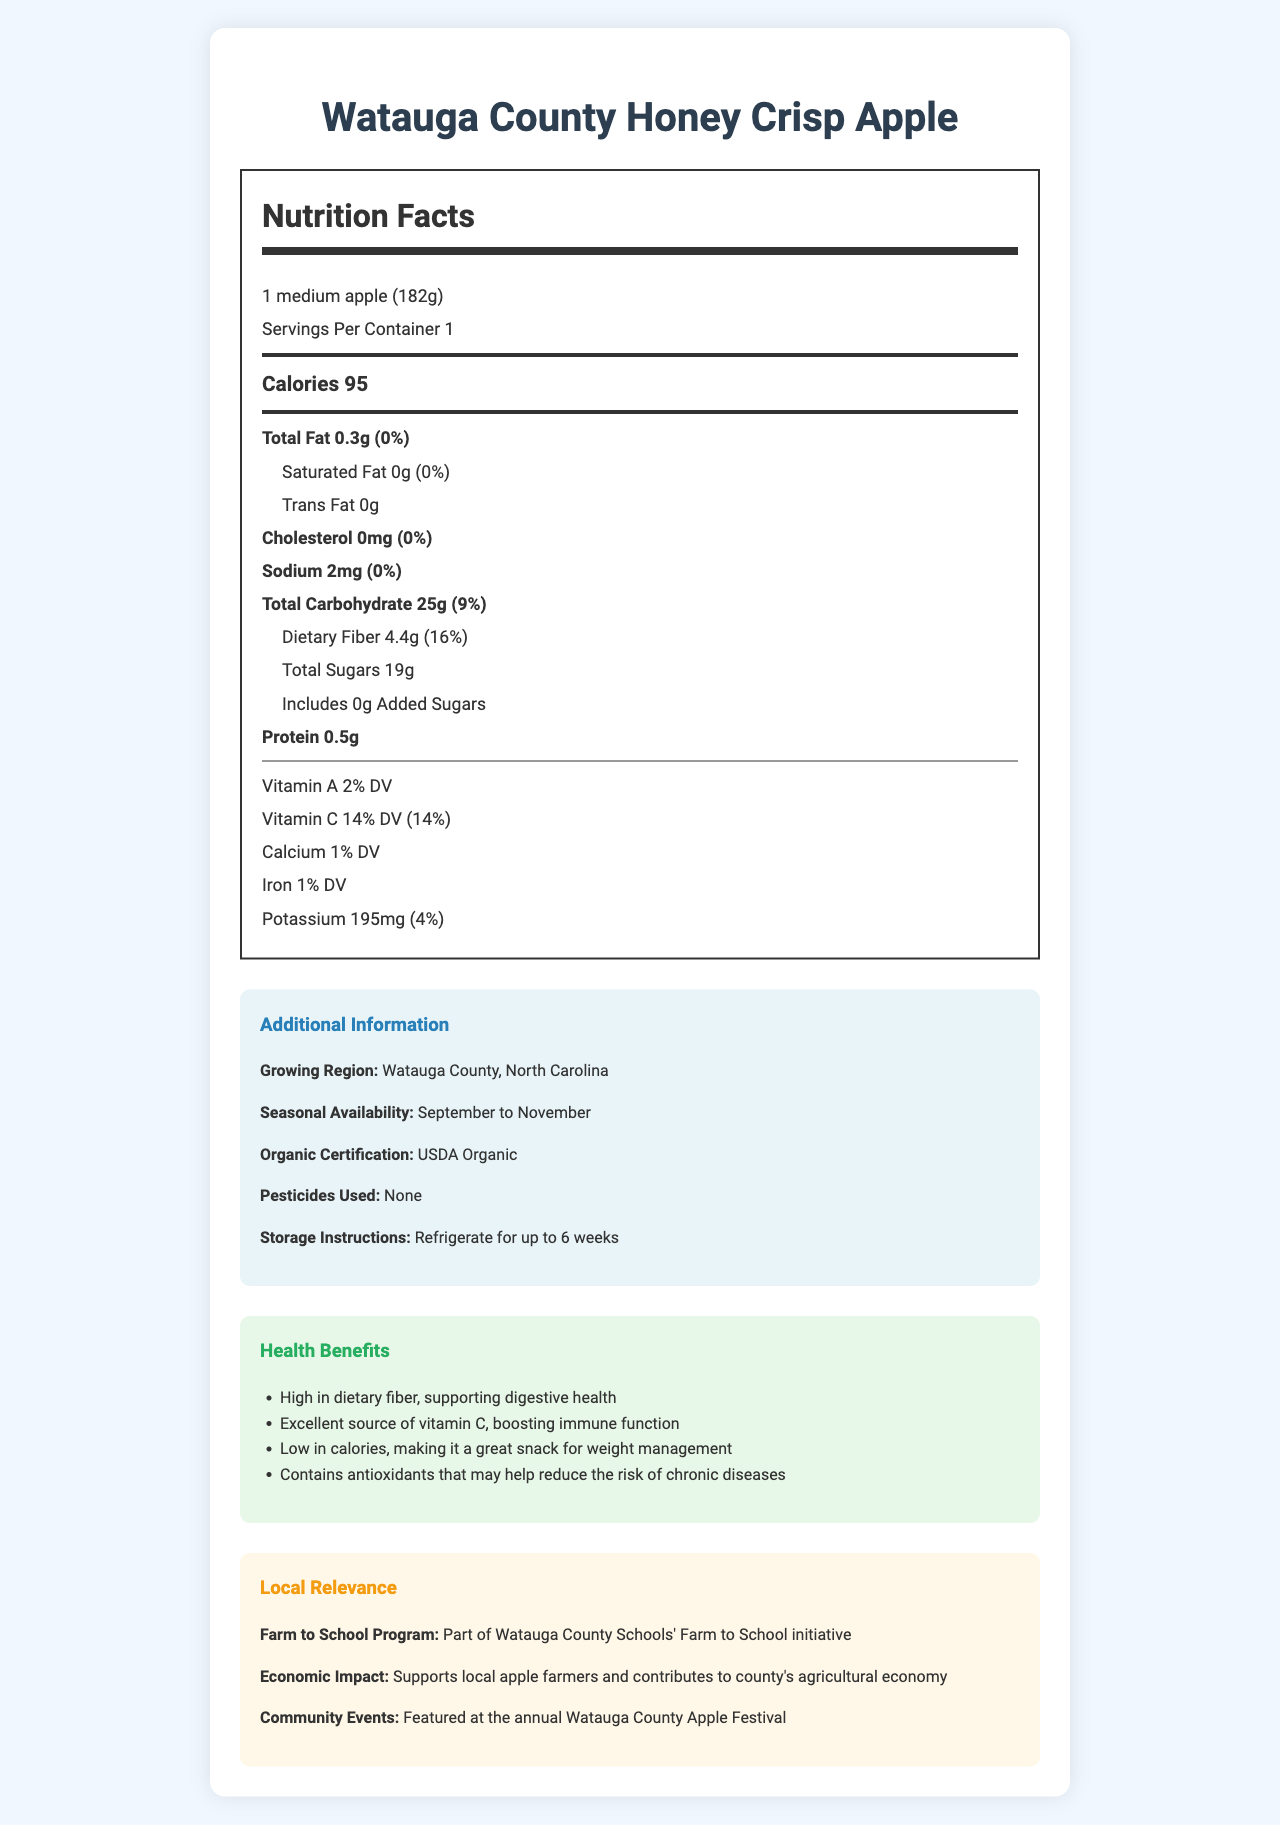what is the serving size of the Watauga County Honey Crisp Apple? The serving size is clearly mentioned at the top of the Nutrition Facts section.
Answer: 1 medium apple (182g) how many calories are there per serving? The document specifies that each serving contains 95 calories.
Answer: 95 calories what percentage of the Daily Value does the dietary fiber in the apple represent? In the Nutrition Facts section, it mentions that the dietary fiber content is 4.4g, which equals 16% of the Daily Value.
Answer: 16% what is the total carbohydrate content per serving? The total carbohydrate content is listed as 25g in the Nutrition Facts section.
Answer: 25g what is the vitamin C percentage of the Daily Value provided by one serving of the apple? The percentage of Daily Value for vitamin C is stated as 14%.
Answer: 14% when is the seasonal availability of the Watauga County Honey Crisp Apple? A. January to March B. April to June C. September to November D. December to February The Additional Information section states that the seasonal availability is September to November.
Answer: C how much protein does a serving of this apple contain? The protein content per serving is indicated as 0.5g in the Nutrition Facts section.
Answer: 0.5g is this apple USDA Organic certified? The Additional Information section confirms that the apple is USDA Organic certified.
Answer: Yes which nutrient has the highest Daily Value percentage? A. Vitamin A B. Vitamin C C. Dietary Fiber D. Potassium The dietary fiber has the highest Daily Value percentage, listed at 16%.
Answer: C are any pesticides used in growing this apple variety? The Additional Information section mentions that no pesticides are used.
Answer: No describe the main idea of the document. The document mainly focuses on giving a comprehensive view of the nutritional benefits and additional relevant details about this local apple variety, aimed at informing consumers and promoting local agriculture.
Answer: The document provides detailed nutritional information about the Watauga County Honey Crisp Apple, highlighting its high fiber and vitamin C content. It includes the serving size, calorie count, and percentages of various nutrients relative to Daily Values. Additionally, it offers additional information about the apple's growing region, availability, organic certification, and storage instructions, along with its health benefits and local relevance. what is the sugar content of the apple? The sugar content per serving is listed in the Nutrition Facts as 19g.
Answer: 19g how many milligrams of potassium does one apple contain? In the Nutrition Facts section, the potassium content is mentioned as 195mg.
Answer: 195mg how long can the apple be stored if refrigerated? The storage instructions in the Additional Information section indicate that the apple can be refrigerated for up to 6 weeks.
Answer: Up to 6 weeks what type of events feature this apple variety in the community? According to the Local Relevance section, this apple variety is featured at the annual Watauga County Apple Festival.
Answer: Watauga County Apple Festival does the apple contain any added sugars? The Nutrition Facts section specifies that the apple contains 0g of added sugars.
Answer: No, it contains 0g of added sugars. what is the economic impact of this local apple variety on Watauga County? The Local Relevance section explains that the apple supports local farmers and contributes to the agricultural economy.
Answer: Supports local apple farmers and contributes to the county's agricultural economy what is the cholesterol content in this apple? The cholesterol content is listed as 0mg in the Nutrition Facts section.
Answer: 0mg explain the health benefits associated with consuming this apple variety. The Health Benefits section outlines how the high fiber and vitamin C content contribute to better digestive and immune health, with additional benefits including low calorie content for weight management and the presence of antioxidants.
Answer: The apple is high in dietary fiber, supporting digestive health, and an excellent source of vitamin C, boosting immune function. It is low in calories, making it a great snack for weight management, and contains antioxidants that may help reduce the risk of chronic diseases. what are the types of fats present in this apple? The Nutrition Facts section lists the total fat as 0.3g, with 0g of both saturated and trans fats.
Answer: Total Fat: 0.3g, Saturated Fat: 0g, Trans Fat: 0g which vitamin has a higher Daily Value percentage, vitamin A or vitamin C? The Daily Value percentage for vitamin A is 2%, while for vitamin C it is 14%, indicating vitamin C has a higher Daily Value percentage.
Answer: Vitamin C what is the growing region for this apple variety? The Additional Information section states that the growing region is Watauga County, North Carolina.
Answer: Watauga County, North Carolina are any artificial sweeteners or flavorings added to this apple? The document does not provide information regarding artificial sweeteners or flavorings.
Answer: Cannot be determined 